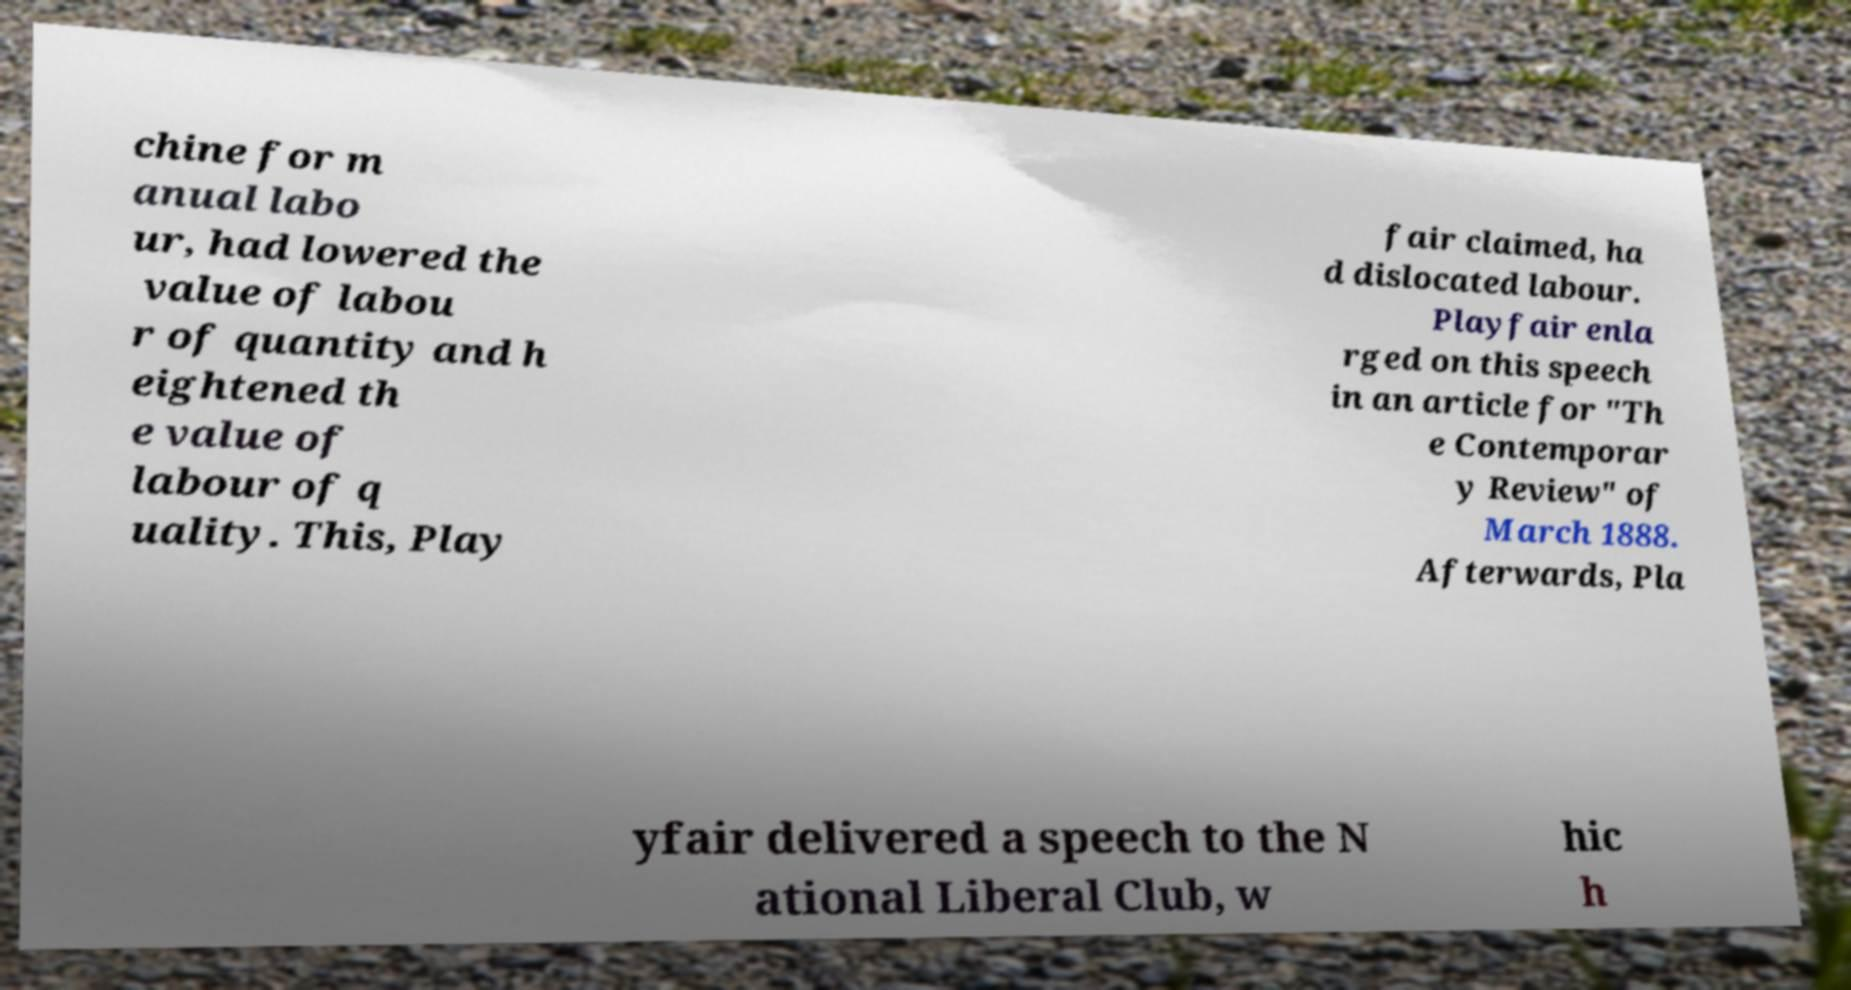Please read and relay the text visible in this image. What does it say? chine for m anual labo ur, had lowered the value of labou r of quantity and h eightened th e value of labour of q uality. This, Play fair claimed, ha d dislocated labour. Playfair enla rged on this speech in an article for "Th e Contemporar y Review" of March 1888. Afterwards, Pla yfair delivered a speech to the N ational Liberal Club, w hic h 